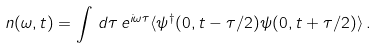<formula> <loc_0><loc_0><loc_500><loc_500>n ( \omega , t ) = \int \, d \tau \, e ^ { i \omega \tau } \langle \psi ^ { \dag } ( 0 , t - \tau / 2 ) \psi ( 0 , t + \tau / 2 ) \rangle \, .</formula> 